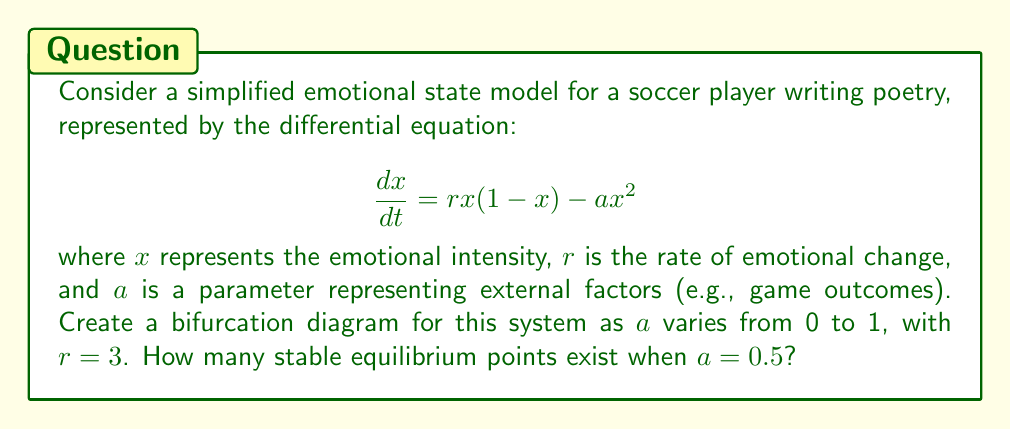Can you answer this question? 1) First, we need to find the equilibrium points of the system by setting the right-hand side of the equation to zero:

   $$rx(1-x) - ax^2 = 0$$

2) Factoring out $x$:

   $$x(r(1-x) - ax) = 0$$

3) This gives us two solutions: $x=0$ and $r(1-x) - ax = 0$

4) Solving the second equation:

   $$r - rx - ax = 0$$
   $$r = x(r + a)$$
   $$x = \frac{r}{r+a}$$

5) To create the bifurcation diagram, we plot these equilibrium points as $a$ varies from 0 to 1, with $r=3$.

6) The stability of each equilibrium point changes when:

   $$a = \frac{r}{4} = \frac{3}{4} = 0.75$$

7) For $a < 0.75$, there are two stable equilibrium points: $x=0$ and $x=\frac{r}{r+a}$

8) For $a > 0.75$, there is only one stable equilibrium point: $x=0$

9) At $a=0.5$, which is less than 0.75, there are two stable equilibrium points.

[asy]
import graph;
size(200,150);
real f(real x, real a) {return 3/(3+a);}
for(real a=0; a<=1; a+=0.01) {
  dot((a,0),blue);
  dot((a,f(x,a)),red);
}
draw((0.75,0)--(0.75,1),dashed);
xlabel("$a$");
ylabel("$x$");
[/asy]
Answer: 2 